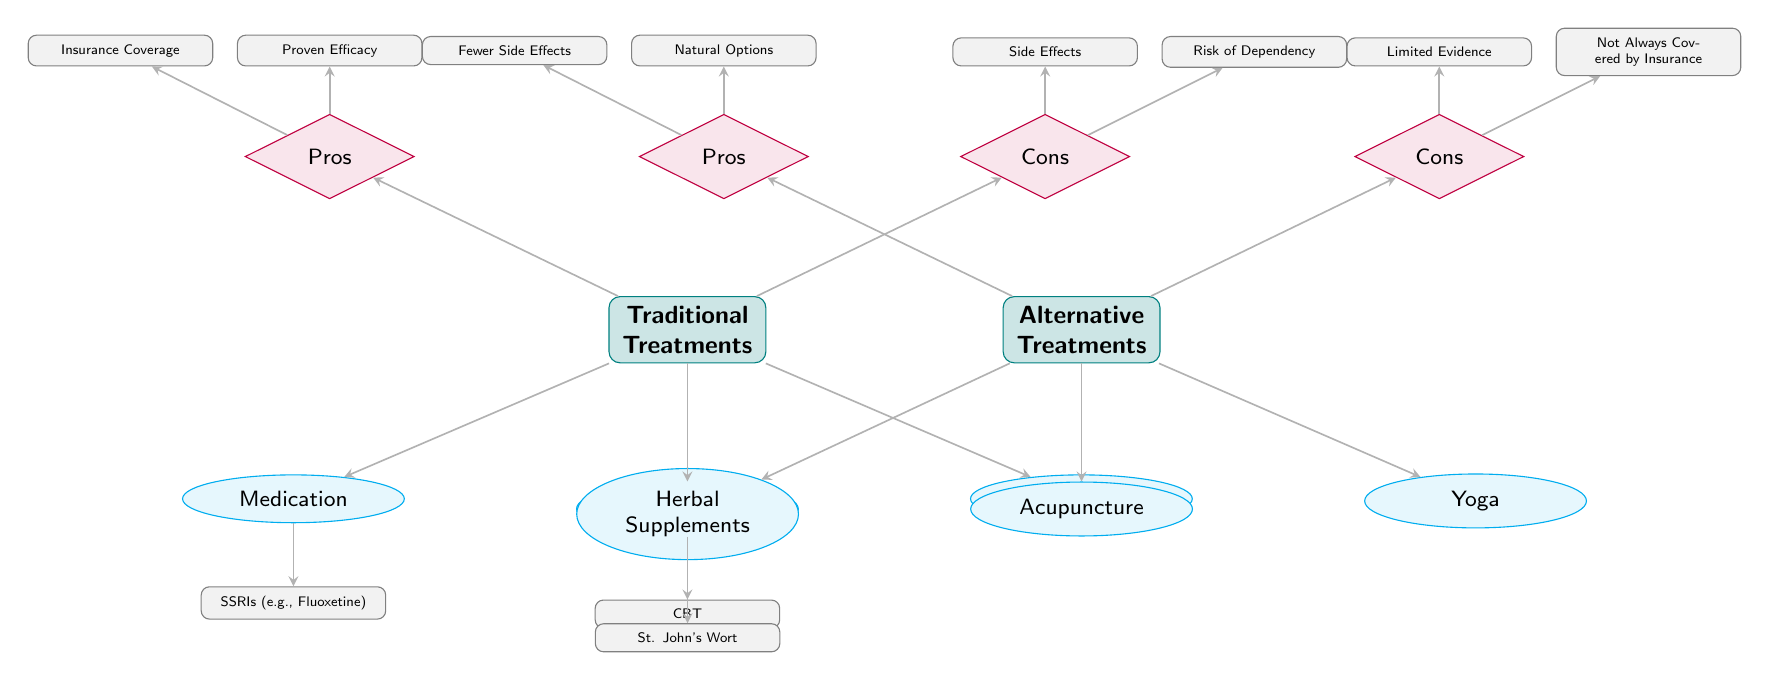What are the three traditional treatments listed in the diagram? The diagram lists three traditional treatments connected directly to the "Traditional Treatments" node: Medication, Psychotherapy, and ECT.
Answer: Medication, Psychotherapy, ECT How many different alternative treatments are shown? The diagram identifies three alternative treatments that branch from the "Alternative Treatments" node: Herbal Supplements, Acupuncture, and Yoga. Therefore, the total count is three.
Answer: Three What specific medication is illustrated under the Medication treatment? The specific medication shown under the Medication treatment node is SSRIs, with the example given as Fluoxetine, indicated below the Medication node.
Answer: SSRIs (e.g., Fluoxetine) What is a pro of traditional treatments according to the diagram? The diagram mentions two pros for traditional treatments. One of them is "Proven Efficacy," which is located above the "Pros" node connected to the traditional treatments.
Answer: Proven Efficacy What is a con of alternative treatments? Among the cons for alternative treatments, "Limited Evidence" is highlighted above the "Cons" node related to alternative treatments in the diagram.
Answer: Limited Evidence Which alternative treatment is directly associated with St. John's Wort? The diagram shows that the herbal supplements category includes St. John's Wort as a specific example beneath the Herbal Supplements node, connecting it directly.
Answer: Herbal Supplements What is an advantage of alternative treatments compared to traditional ones? The diagram presents "Natural Options" and "Fewer Side Effects" as pros of alternative treatments, implying they are seen as advantages compared to traditional treatments.
Answer: Natural Options What is a risk associated with traditional treatments? The diagram lists "Risk of Dependency" as one of the cons associated with traditional treatments, indicating a potential negative consequence of these treatments.
Answer: Risk of Dependency 